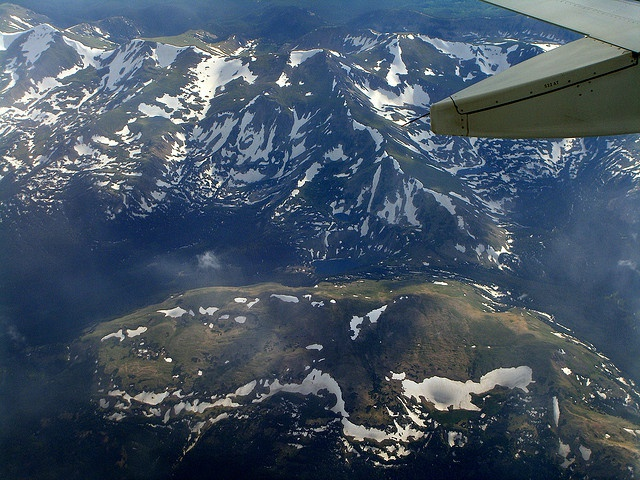Describe the objects in this image and their specific colors. I can see a airplane in gray, darkgray, black, and darkgreen tones in this image. 